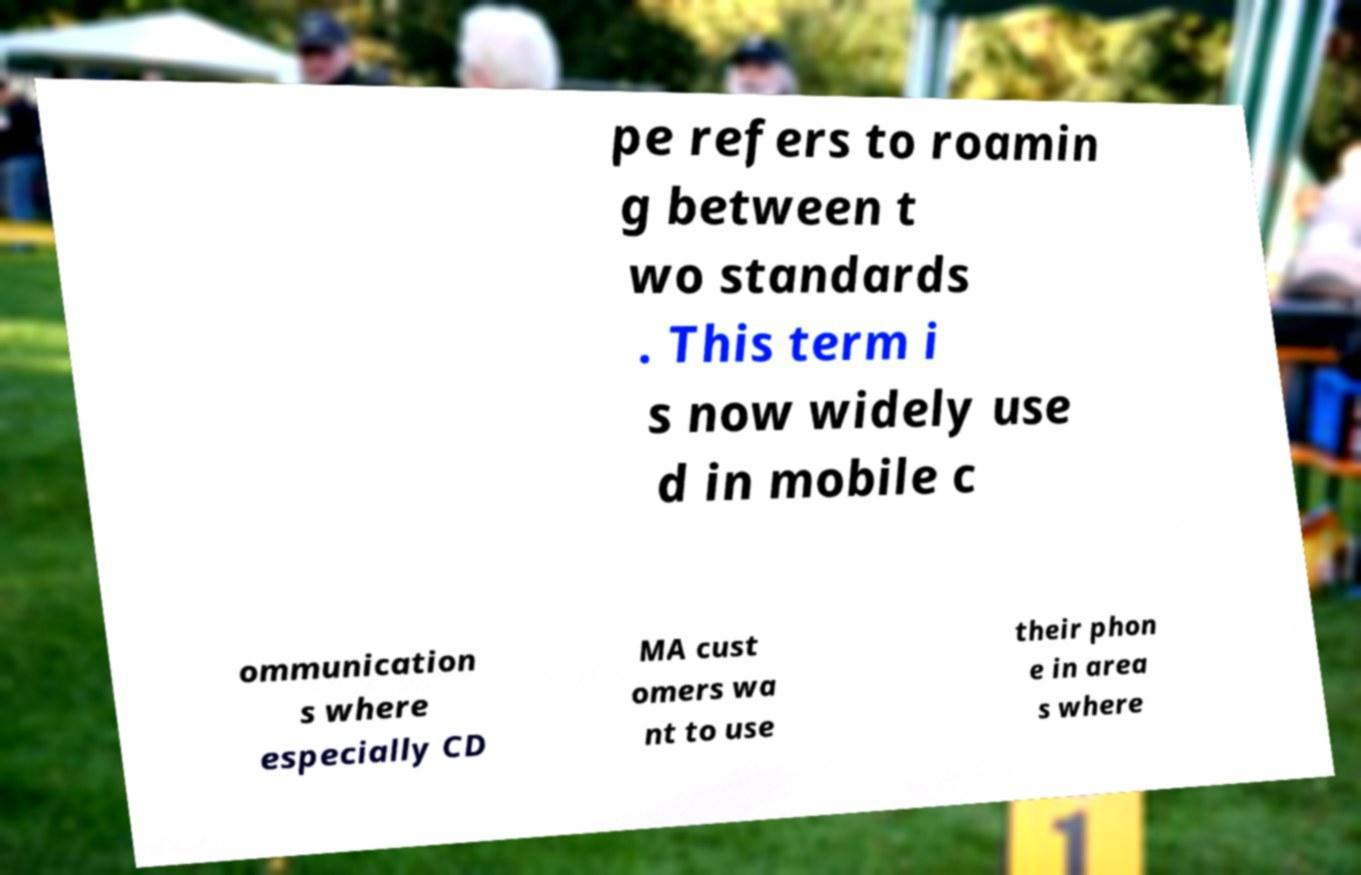Can you accurately transcribe the text from the provided image for me? pe refers to roamin g between t wo standards . This term i s now widely use d in mobile c ommunication s where especially CD MA cust omers wa nt to use their phon e in area s where 